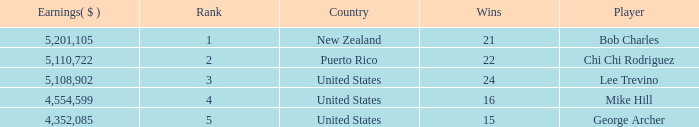On average, how many wins have a rank lower than 1? None. 